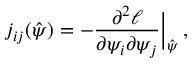Convert formula to latex. <formula><loc_0><loc_0><loc_500><loc_500>j _ { i j } ( \hat { \psi } ) = - \frac { \partial ^ { 2 } \ell } { \partial \psi _ { i } \partial \psi _ { j } } \Big | _ { \hat { \psi } } \, ,</formula> 